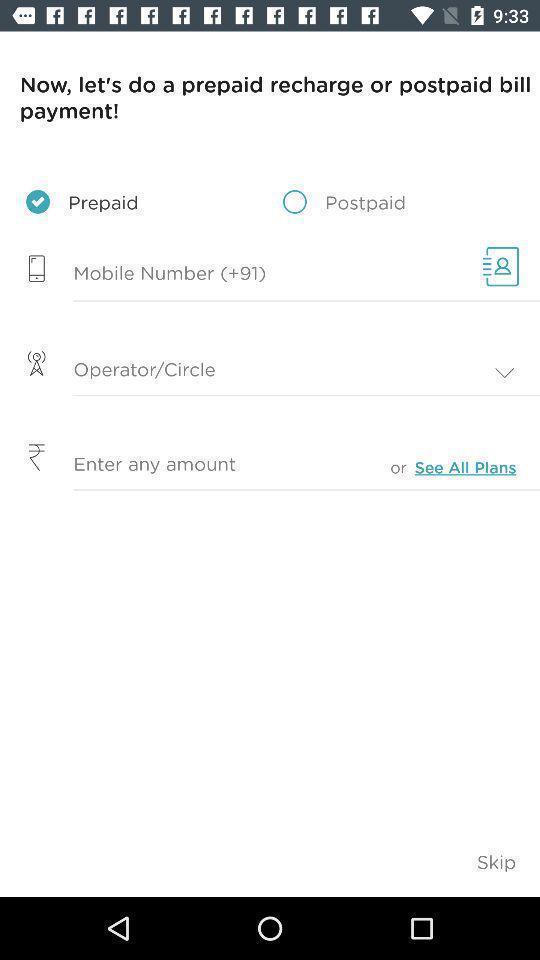Explain the elements present in this screenshot. Select a bill payment of recharge. 